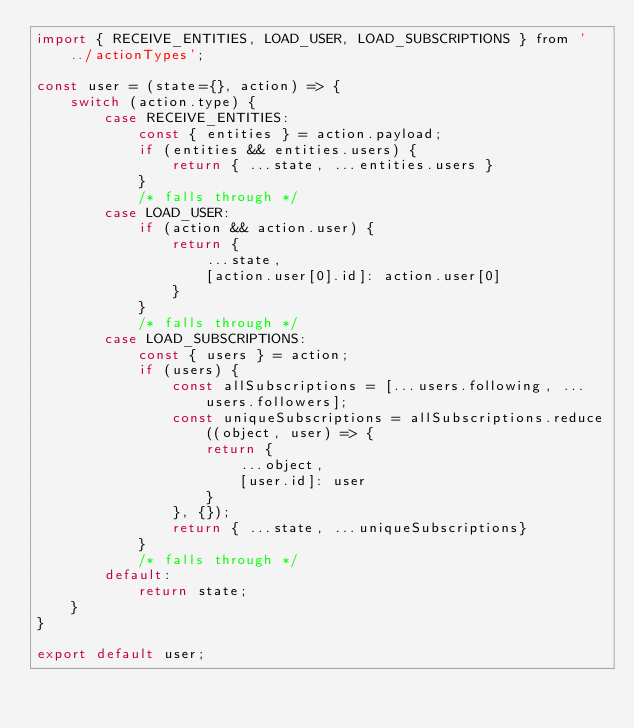Convert code to text. <code><loc_0><loc_0><loc_500><loc_500><_JavaScript_>import { RECEIVE_ENTITIES, LOAD_USER, LOAD_SUBSCRIPTIONS } from '../actionTypes';

const user = (state={}, action) => {
    switch (action.type) {
        case RECEIVE_ENTITIES:
            const { entities } = action.payload;
            if (entities && entities.users) {
                return { ...state, ...entities.users }
            } 
            /* falls through */
        case LOAD_USER:
            if (action && action.user) {
                return { 
                    ...state,
                    [action.user[0].id]: action.user[0]
                }
            }
            /* falls through */
        case LOAD_SUBSCRIPTIONS:
            const { users } = action;
            if (users) {
                const allSubscriptions = [...users.following, ...users.followers];
                const uniqueSubscriptions = allSubscriptions.reduce((object, user) => {
                    return {
                        ...object,
                        [user.id]: user
                    }
                }, {});
                return { ...state, ...uniqueSubscriptions}
            }
            /* falls through */
        default:
            return state;
    }
}

export default user;</code> 